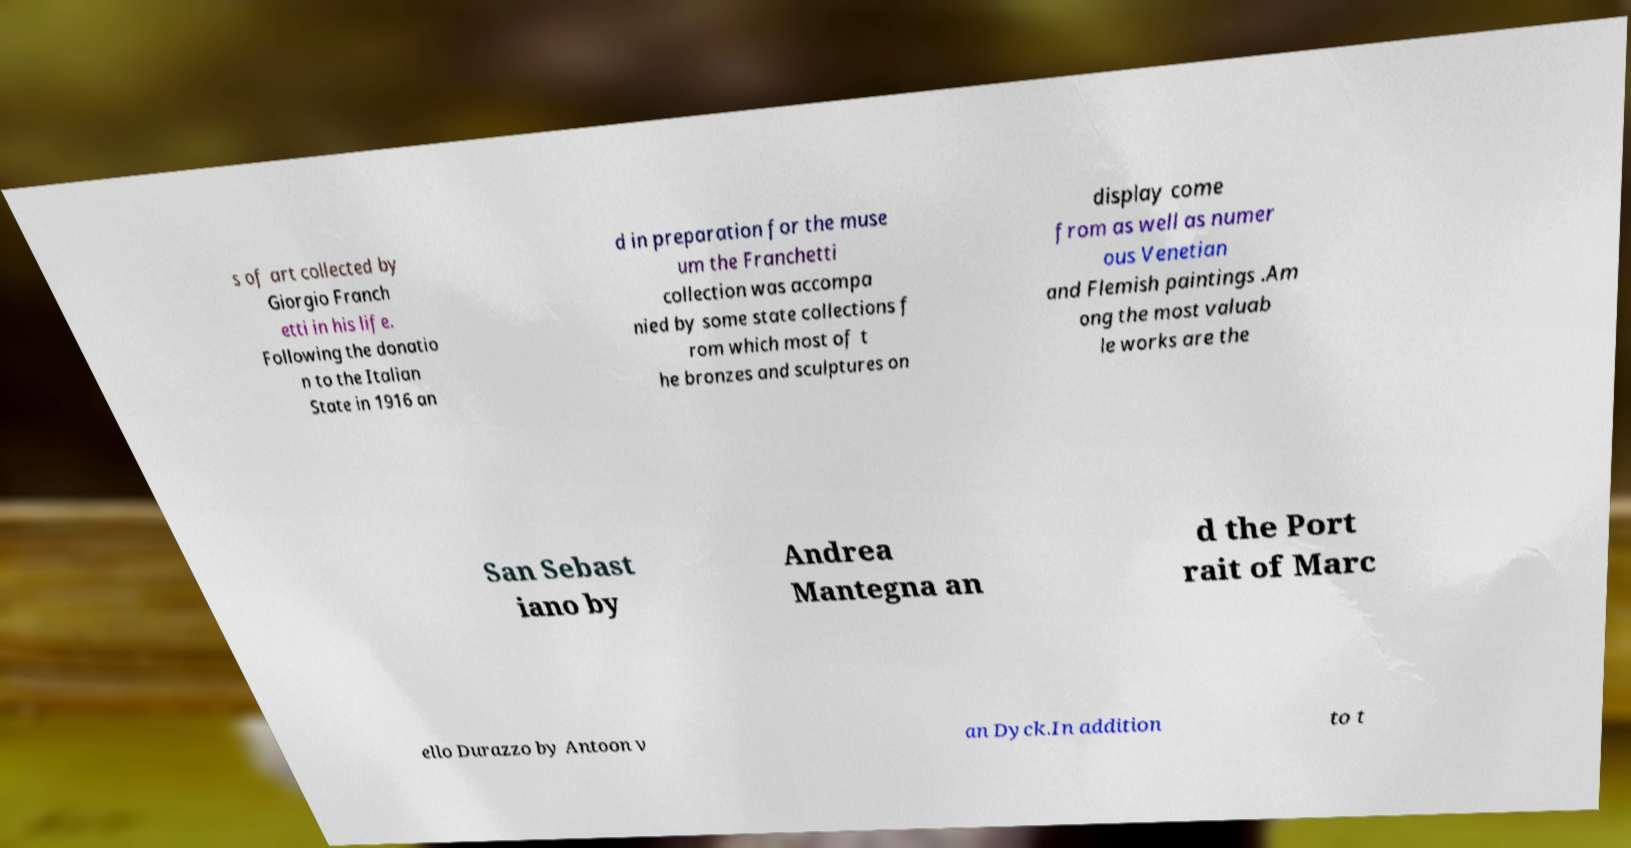Can you accurately transcribe the text from the provided image for me? s of art collected by Giorgio Franch etti in his life. Following the donatio n to the Italian State in 1916 an d in preparation for the muse um the Franchetti collection was accompa nied by some state collections f rom which most of t he bronzes and sculptures on display come from as well as numer ous Venetian and Flemish paintings .Am ong the most valuab le works are the San Sebast iano by Andrea Mantegna an d the Port rait of Marc ello Durazzo by Antoon v an Dyck.In addition to t 